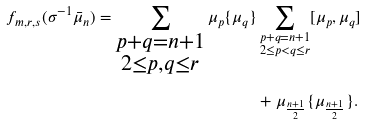<formula> <loc_0><loc_0><loc_500><loc_500>f _ { m , r , s } ( \sigma ^ { - 1 } \bar { \mu } _ { n } ) = \sum _ { \substack { p + q = n + 1 \\ 2 \leq p , q \leq r } } \mu _ { p } \{ \mu _ { q } \} & \sum _ { \substack { p + q = n + 1 \\ 2 \leq p < q \leq r } } [ \mu _ { p } , \mu _ { q } ] \\ & + \mu _ { \frac { n + 1 } { 2 } } \{ \mu _ { \frac { n + 1 } { 2 } } \} .</formula> 